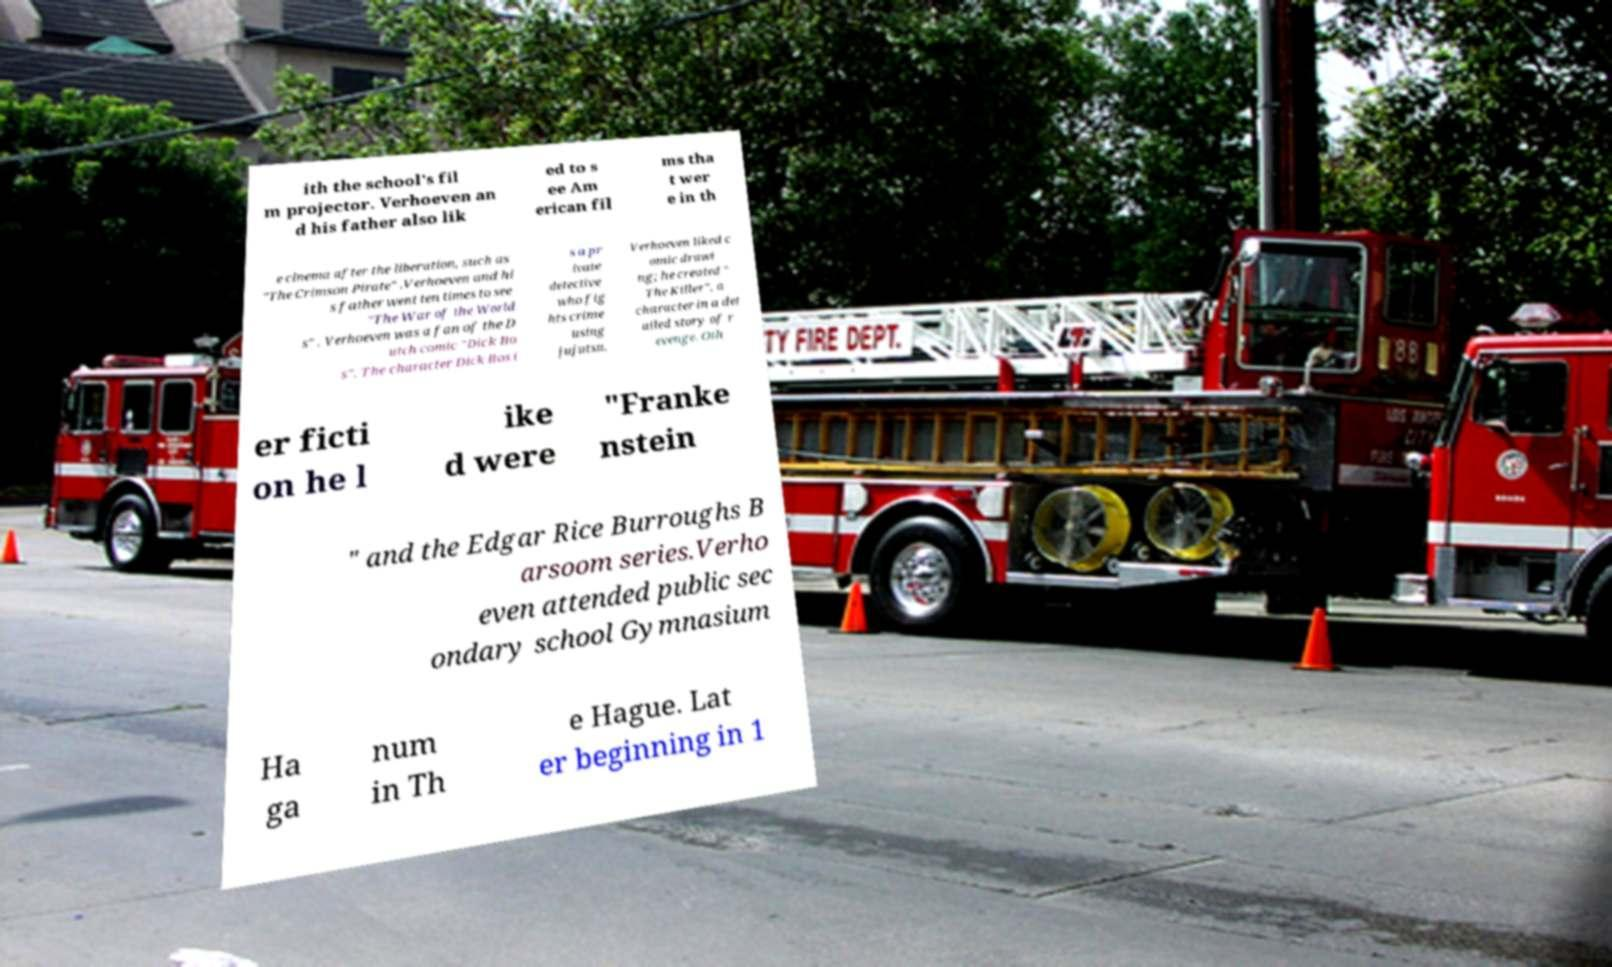I need the written content from this picture converted into text. Can you do that? ith the school's fil m projector. Verhoeven an d his father also lik ed to s ee Am erican fil ms tha t wer e in th e cinema after the liberation, such as "The Crimson Pirate" .Verhoeven and hi s father went ten times to see "The War of the World s" . Verhoeven was a fan of the D utch comic "Dick Bo s". The character Dick Bos i s a pr ivate detective who fig hts crime using jujutsu. Verhoeven liked c omic drawi ng; he created " The Killer", a character in a det ailed story of r evenge. Oth er ficti on he l ike d were "Franke nstein " and the Edgar Rice Burroughs B arsoom series.Verho even attended public sec ondary school Gymnasium Ha ga num in Th e Hague. Lat er beginning in 1 